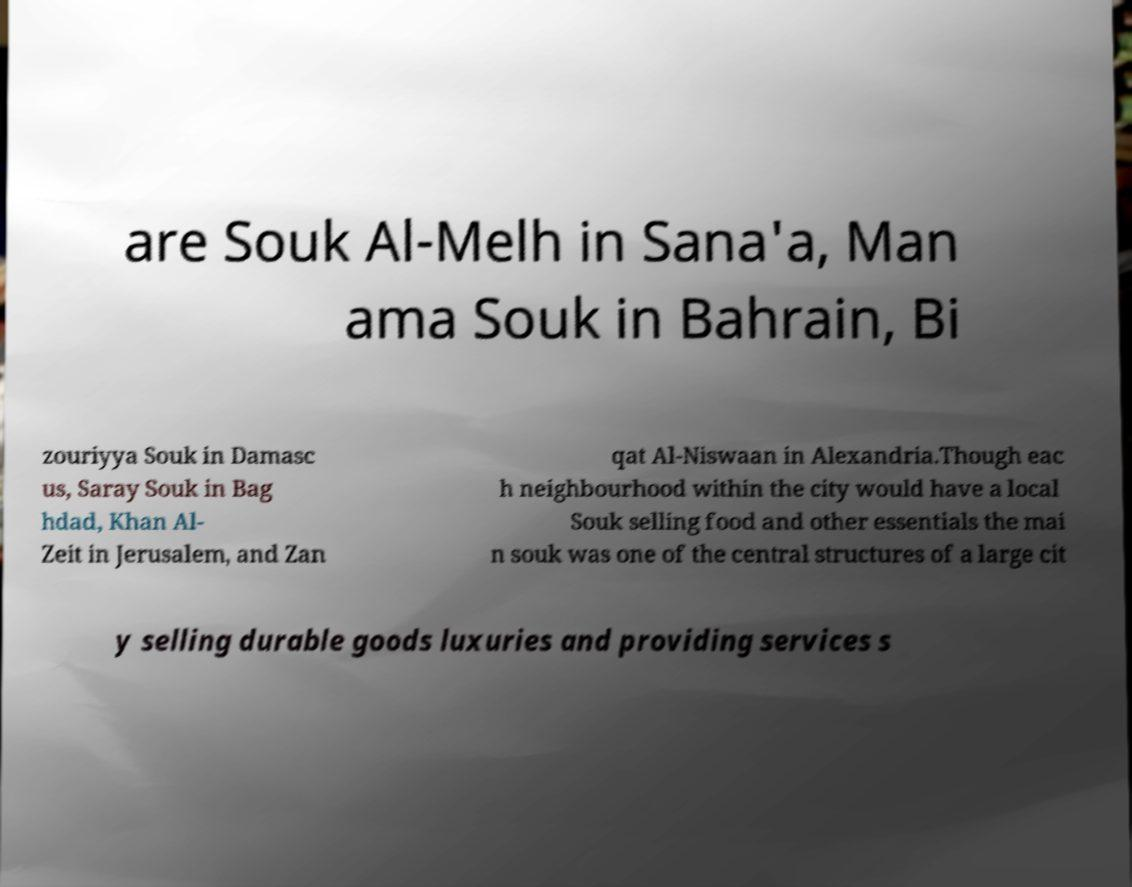I need the written content from this picture converted into text. Can you do that? are Souk Al-Melh in Sana'a, Man ama Souk in Bahrain, Bi zouriyya Souk in Damasc us, Saray Souk in Bag hdad, Khan Al- Zeit in Jerusalem, and Zan qat Al-Niswaan in Alexandria.Though eac h neighbourhood within the city would have a local Souk selling food and other essentials the mai n souk was one of the central structures of a large cit y selling durable goods luxuries and providing services s 